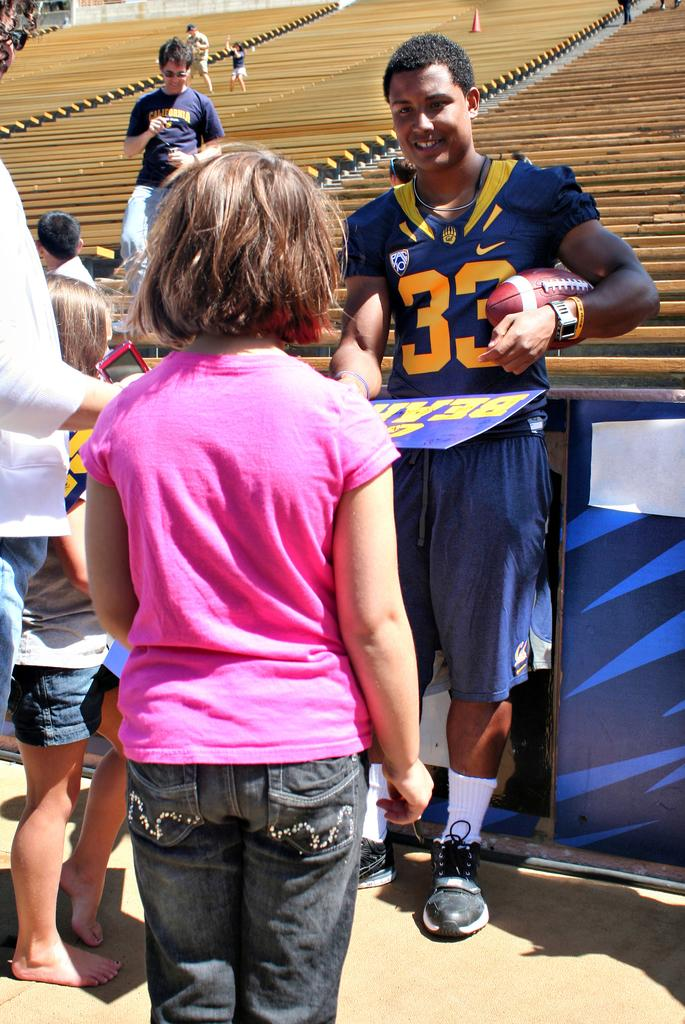Provide a one-sentence caption for the provided image. A Cal football player wearing number 33 signs autographs for fans. 